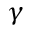Convert formula to latex. <formula><loc_0><loc_0><loc_500><loc_500>\gamma</formula> 